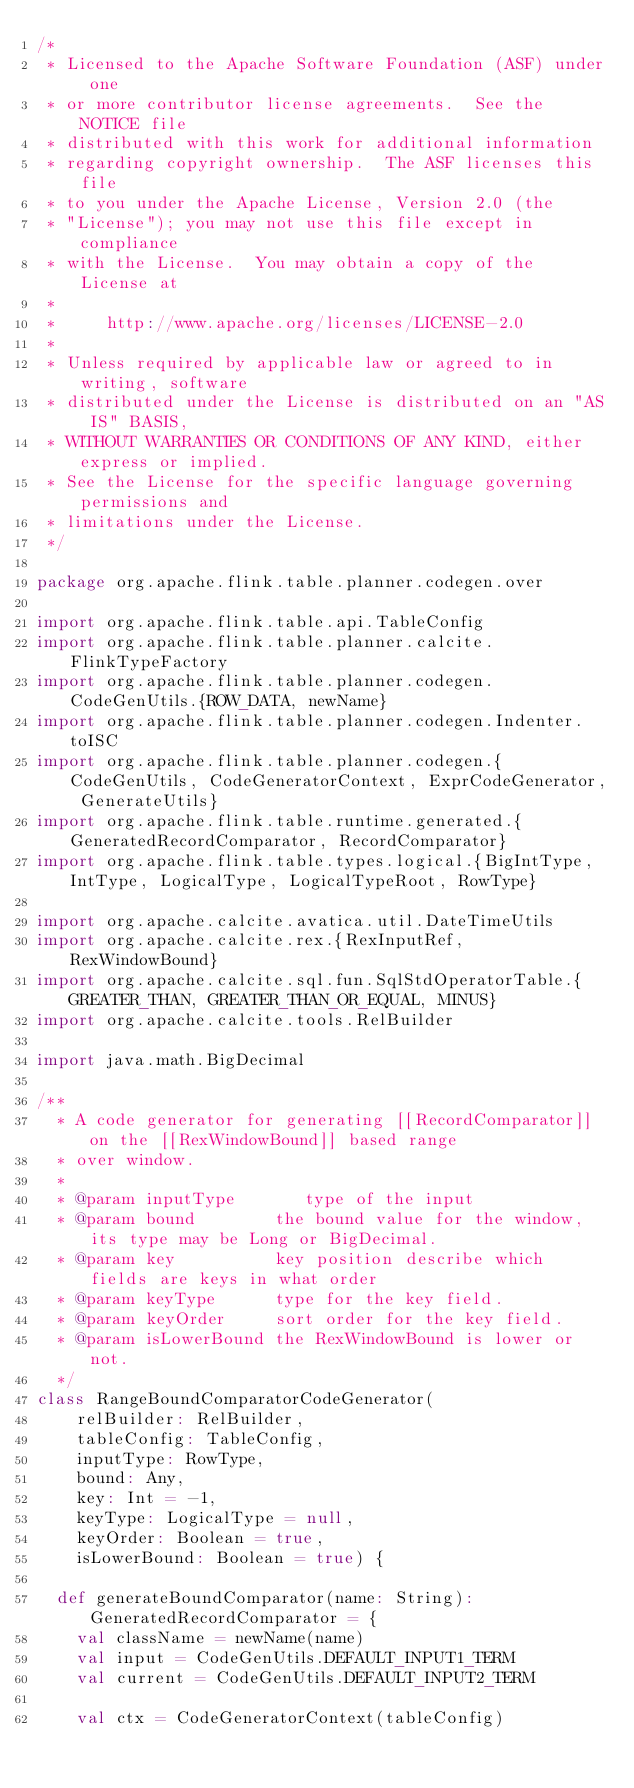Convert code to text. <code><loc_0><loc_0><loc_500><loc_500><_Scala_>/*
 * Licensed to the Apache Software Foundation (ASF) under one
 * or more contributor license agreements.  See the NOTICE file
 * distributed with this work for additional information
 * regarding copyright ownership.  The ASF licenses this file
 * to you under the Apache License, Version 2.0 (the
 * "License"); you may not use this file except in compliance
 * with the License.  You may obtain a copy of the License at
 *
 *     http://www.apache.org/licenses/LICENSE-2.0
 *
 * Unless required by applicable law or agreed to in writing, software
 * distributed under the License is distributed on an "AS IS" BASIS,
 * WITHOUT WARRANTIES OR CONDITIONS OF ANY KIND, either express or implied.
 * See the License for the specific language governing permissions and
 * limitations under the License.
 */

package org.apache.flink.table.planner.codegen.over

import org.apache.flink.table.api.TableConfig
import org.apache.flink.table.planner.calcite.FlinkTypeFactory
import org.apache.flink.table.planner.codegen.CodeGenUtils.{ROW_DATA, newName}
import org.apache.flink.table.planner.codegen.Indenter.toISC
import org.apache.flink.table.planner.codegen.{CodeGenUtils, CodeGeneratorContext, ExprCodeGenerator, GenerateUtils}
import org.apache.flink.table.runtime.generated.{GeneratedRecordComparator, RecordComparator}
import org.apache.flink.table.types.logical.{BigIntType, IntType, LogicalType, LogicalTypeRoot, RowType}

import org.apache.calcite.avatica.util.DateTimeUtils
import org.apache.calcite.rex.{RexInputRef, RexWindowBound}
import org.apache.calcite.sql.fun.SqlStdOperatorTable.{GREATER_THAN, GREATER_THAN_OR_EQUAL, MINUS}
import org.apache.calcite.tools.RelBuilder

import java.math.BigDecimal

/**
  * A code generator for generating [[RecordComparator]] on the [[RexWindowBound]] based range
  * over window.
  *
  * @param inputType       type of the input
  * @param bound        the bound value for the window, its type may be Long or BigDecimal.
  * @param key          key position describe which fields are keys in what order
  * @param keyType      type for the key field.
  * @param keyOrder     sort order for the key field.
  * @param isLowerBound the RexWindowBound is lower or not.
  */
class RangeBoundComparatorCodeGenerator(
    relBuilder: RelBuilder,
    tableConfig: TableConfig,
    inputType: RowType,
    bound: Any,
    key: Int = -1,
    keyType: LogicalType = null,
    keyOrder: Boolean = true,
    isLowerBound: Boolean = true) {

  def generateBoundComparator(name: String): GeneratedRecordComparator = {
    val className = newName(name)
    val input = CodeGenUtils.DEFAULT_INPUT1_TERM
    val current = CodeGenUtils.DEFAULT_INPUT2_TERM

    val ctx = CodeGeneratorContext(tableConfig)
</code> 